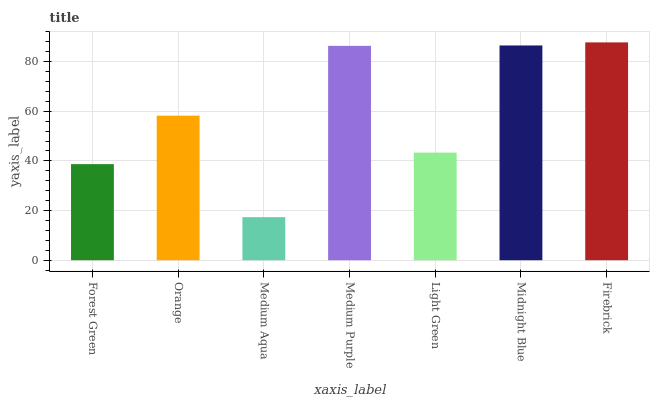Is Orange the minimum?
Answer yes or no. No. Is Orange the maximum?
Answer yes or no. No. Is Orange greater than Forest Green?
Answer yes or no. Yes. Is Forest Green less than Orange?
Answer yes or no. Yes. Is Forest Green greater than Orange?
Answer yes or no. No. Is Orange less than Forest Green?
Answer yes or no. No. Is Orange the high median?
Answer yes or no. Yes. Is Orange the low median?
Answer yes or no. Yes. Is Medium Purple the high median?
Answer yes or no. No. Is Midnight Blue the low median?
Answer yes or no. No. 